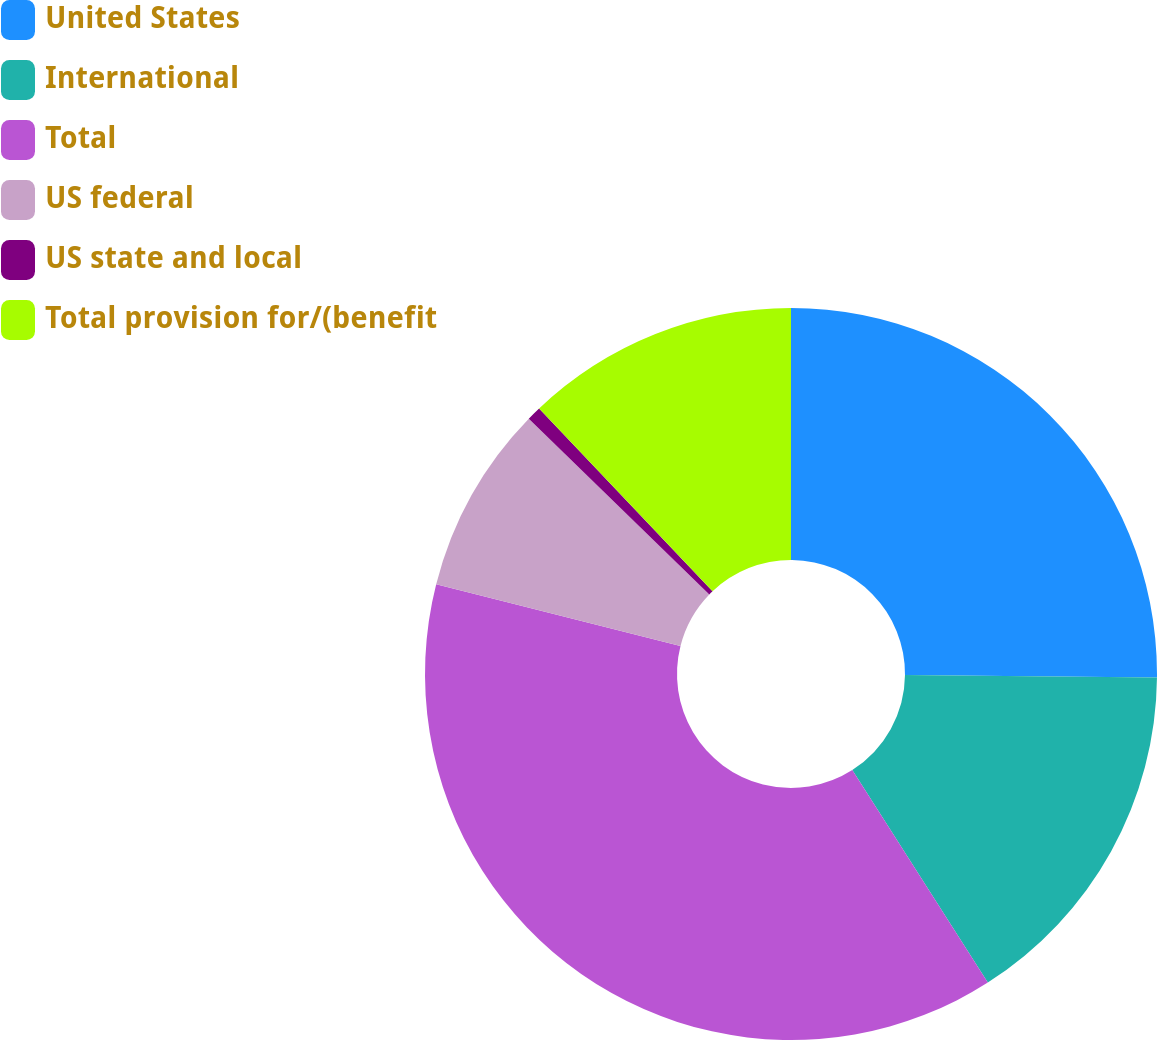Convert chart. <chart><loc_0><loc_0><loc_500><loc_500><pie_chart><fcel>United States<fcel>International<fcel>Total<fcel>US federal<fcel>US state and local<fcel>Total provision for/(benefit<nl><fcel>25.15%<fcel>15.81%<fcel>37.98%<fcel>8.34%<fcel>0.63%<fcel>12.08%<nl></chart> 